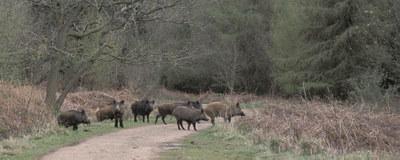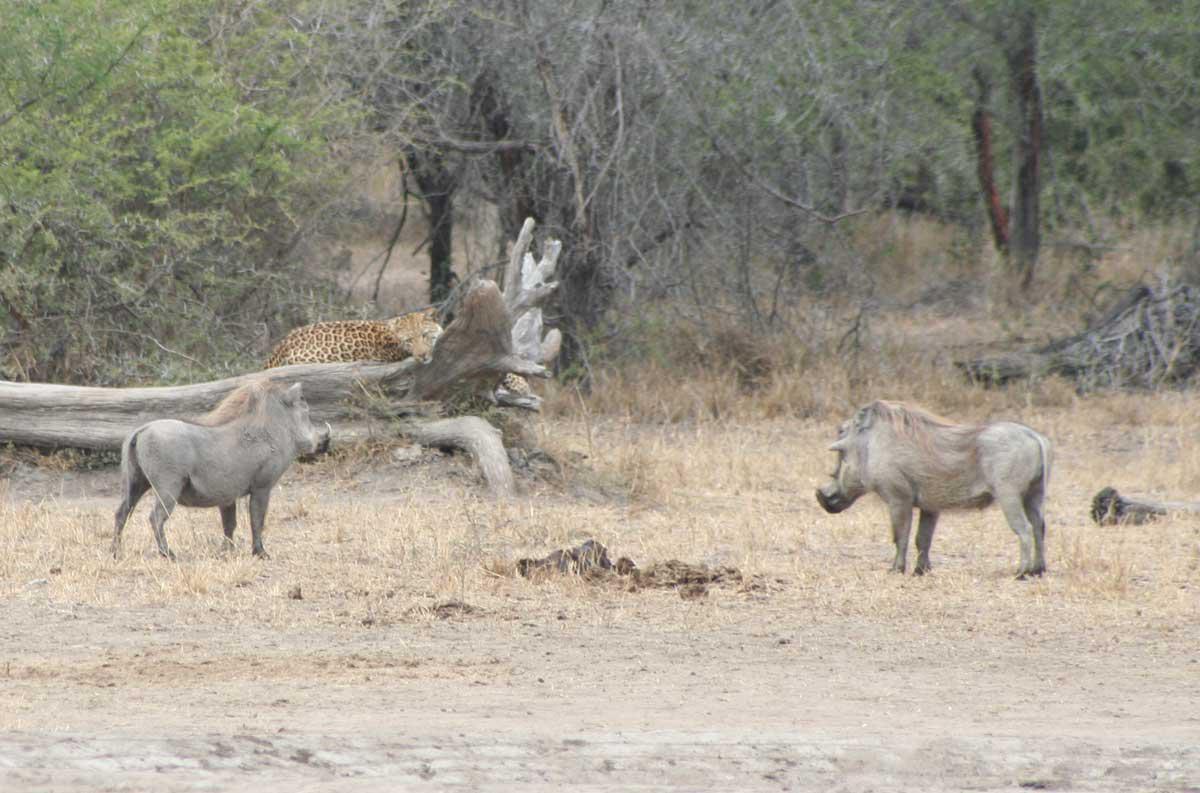The first image is the image on the left, the second image is the image on the right. For the images shown, is this caption "Every picture has more than 6 pigs" true? Answer yes or no. No. 